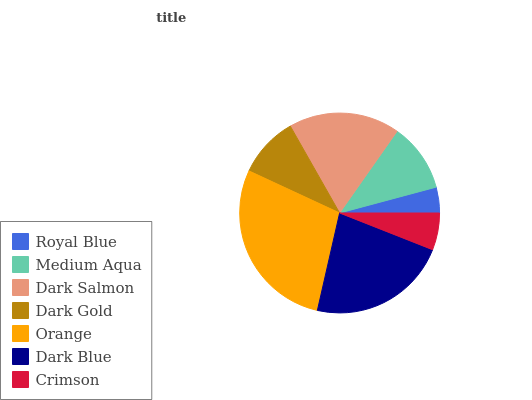Is Royal Blue the minimum?
Answer yes or no. Yes. Is Orange the maximum?
Answer yes or no. Yes. Is Medium Aqua the minimum?
Answer yes or no. No. Is Medium Aqua the maximum?
Answer yes or no. No. Is Medium Aqua greater than Royal Blue?
Answer yes or no. Yes. Is Royal Blue less than Medium Aqua?
Answer yes or no. Yes. Is Royal Blue greater than Medium Aqua?
Answer yes or no. No. Is Medium Aqua less than Royal Blue?
Answer yes or no. No. Is Medium Aqua the high median?
Answer yes or no. Yes. Is Medium Aqua the low median?
Answer yes or no. Yes. Is Royal Blue the high median?
Answer yes or no. No. Is Dark Salmon the low median?
Answer yes or no. No. 